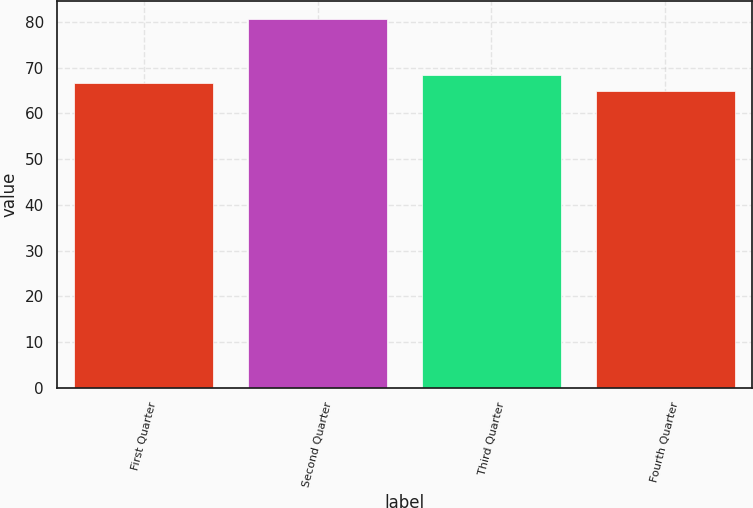Convert chart to OTSL. <chart><loc_0><loc_0><loc_500><loc_500><bar_chart><fcel>First Quarter<fcel>Second Quarter<fcel>Third Quarter<fcel>Fourth Quarter<nl><fcel>66.54<fcel>80.54<fcel>68.29<fcel>64.9<nl></chart> 